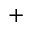<formula> <loc_0><loc_0><loc_500><loc_500>^ { + }</formula> 